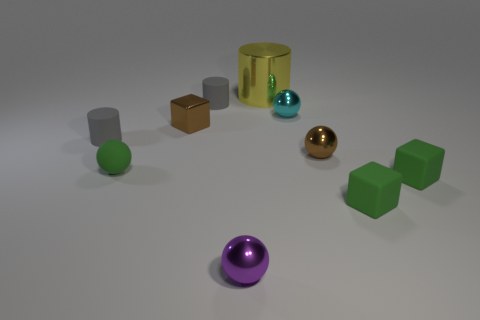Subtract all small purple metal spheres. How many spheres are left? 3 Subtract all yellow cylinders. How many green blocks are left? 2 Subtract all purple balls. How many balls are left? 3 Subtract all cubes. How many objects are left? 7 Subtract 1 cubes. How many cubes are left? 2 Subtract all green cubes. Subtract all gray spheres. How many cubes are left? 1 Add 5 big yellow metallic objects. How many big yellow metallic objects are left? 6 Add 6 yellow shiny cylinders. How many yellow shiny cylinders exist? 7 Subtract 0 cyan blocks. How many objects are left? 10 Subtract all red spheres. Subtract all tiny brown shiny objects. How many objects are left? 8 